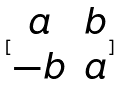Convert formula to latex. <formula><loc_0><loc_0><loc_500><loc_500>[ \begin{matrix} a & b \\ - b & a \end{matrix} ]</formula> 